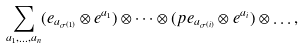<formula> <loc_0><loc_0><loc_500><loc_500>\sum _ { a _ { 1 } , \dots , a _ { n } } ( e _ { a _ { \sigma ( 1 ) } } \otimes e ^ { a _ { 1 } } ) \otimes \dots \otimes ( p e _ { a _ { \sigma ( i ) } } \otimes e ^ { a _ { i } } ) \otimes \dots ,</formula> 